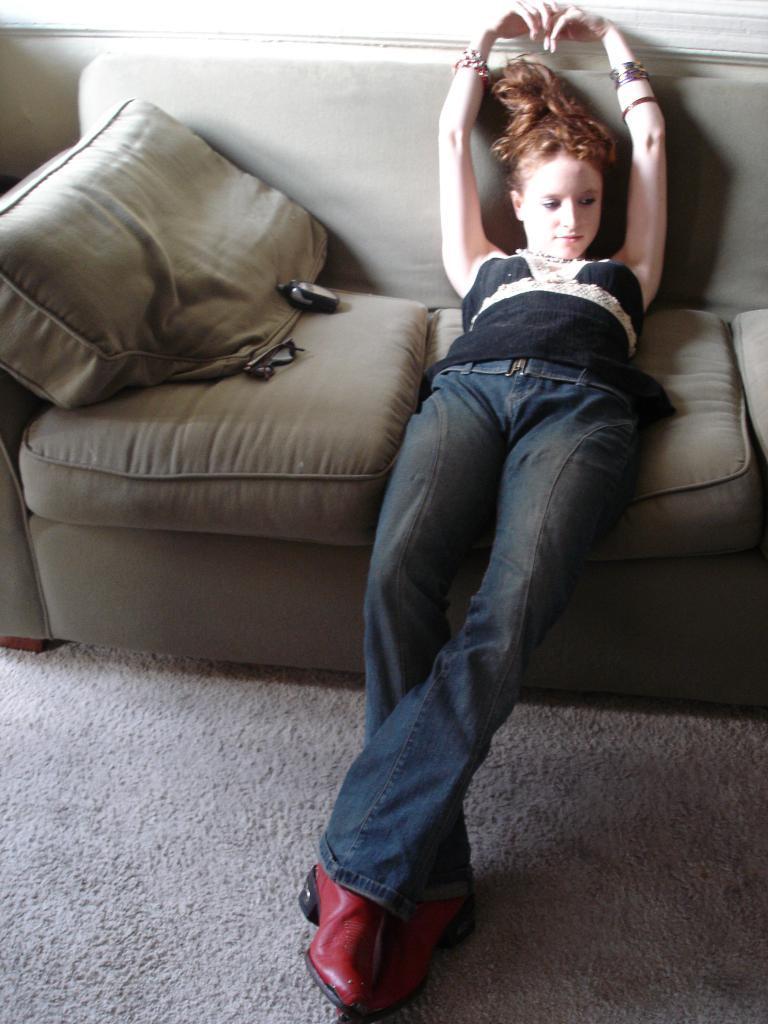Could you give a brief overview of what you see in this image? In this image, there is a sofa which is in gray color, on that sofa there is a girl sitting and there are some black color objects on the sofa. 